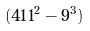Convert formula to latex. <formula><loc_0><loc_0><loc_500><loc_500>( 4 1 1 ^ { 2 } - 9 ^ { 3 } )</formula> 